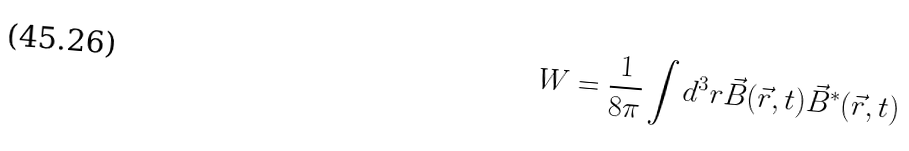<formula> <loc_0><loc_0><loc_500><loc_500>W = \frac { 1 } { 8 \pi } \int d ^ { 3 } r \vec { B } ( \vec { r } , t ) \vec { B } ^ { * } ( \vec { r } , t )</formula> 